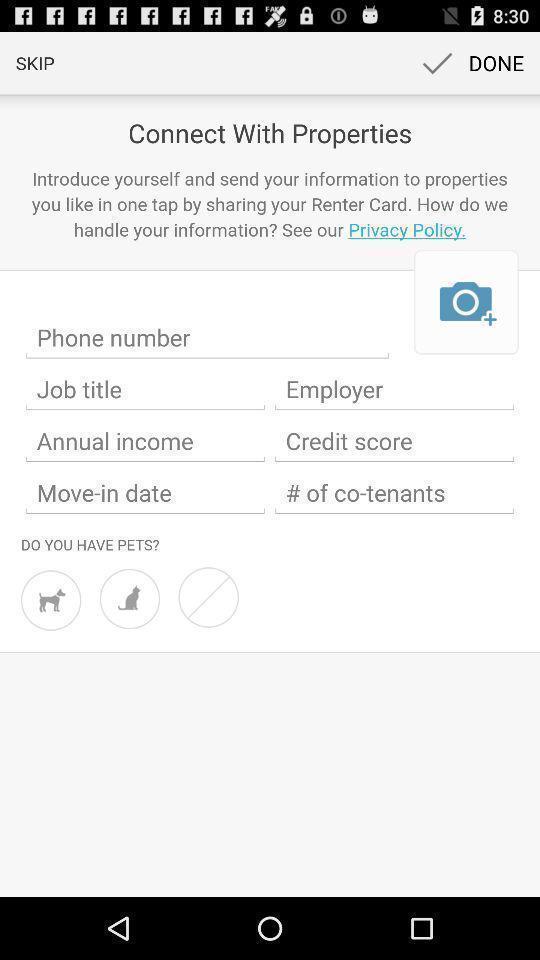What can you discern from this picture? Page displaying various details to be filled. 